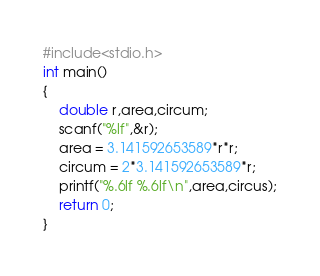<code> <loc_0><loc_0><loc_500><loc_500><_C_>#include<stdio.h>
int main()
{
    double r,area,circum;
    scanf("%lf",&r);
    area = 3.141592653589*r*r;
    circum = 2*3.141592653589*r;
    printf("%.6lf %.6lf\n",area,circus);
    return 0;
}

</code> 